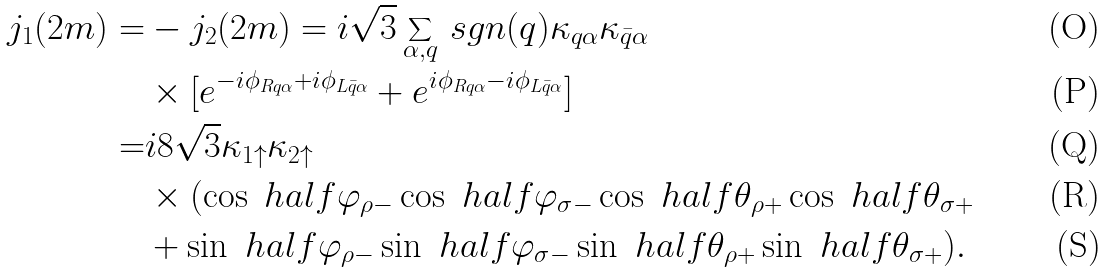<formula> <loc_0><loc_0><loc_500><loc_500>j _ { 1 } ( 2 m ) = & - j _ { 2 } ( 2 m ) = i \sqrt { 3 } \sum _ { \alpha , q } \, s g n ( q ) \kappa _ { q \alpha } \kappa _ { \bar { q } \alpha } \\ & \times [ e ^ { - i \phi _ { R q \alpha } + i \phi _ { L \bar { q } \alpha } } + e ^ { i \phi _ { R q \alpha } - i \phi _ { L \bar { q } \alpha } } ] \\ = & i 8 \sqrt { 3 } \kappa _ { 1 \uparrow } \kappa _ { 2 \uparrow } \\ & \times ( \cos \ h a l f \varphi _ { \rho - } \cos \ h a l f \varphi _ { \sigma - } \cos \ h a l f \theta _ { \rho + } \cos \ h a l f \theta _ { \sigma + } \\ & + \sin \ h a l f \varphi _ { \rho - } \sin \ h a l f \varphi _ { \sigma - } \sin \ h a l f \theta _ { \rho + } \sin \ h a l f \theta _ { \sigma + } ) .</formula> 